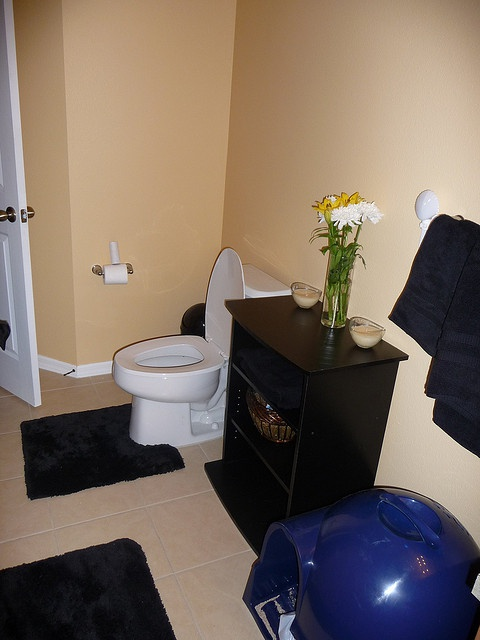Describe the objects in this image and their specific colors. I can see toilet in black, darkgray, lightgray, and gray tones, potted plant in black, darkgreen, lightgray, and tan tones, vase in black, darkgreen, and olive tones, bowl in black, tan, and gray tones, and bowl in black, tan, and gray tones in this image. 